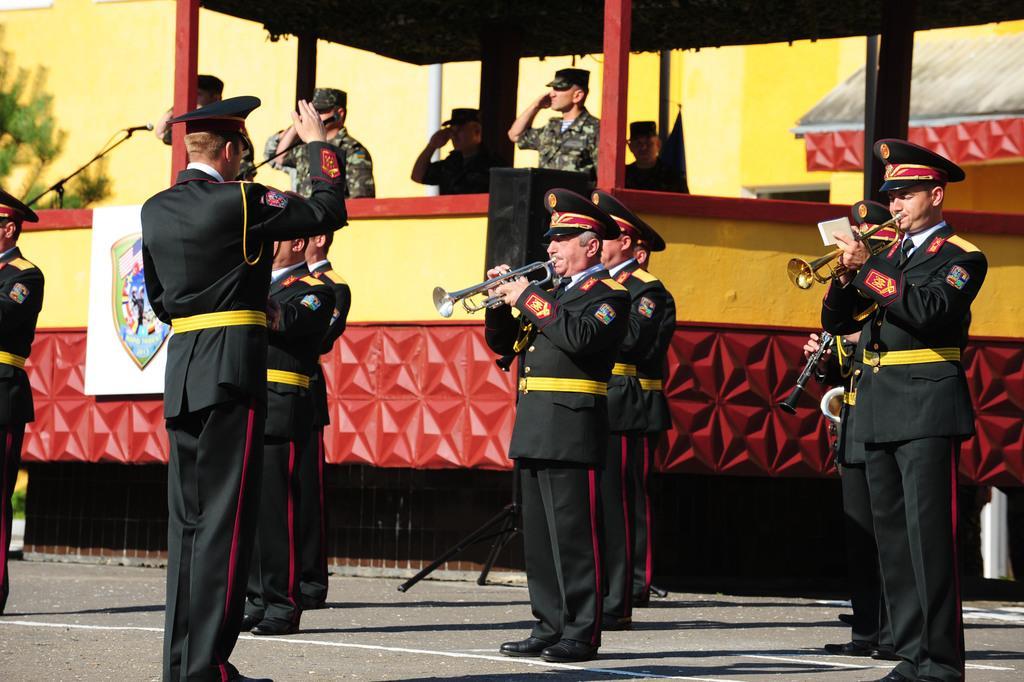Please provide a concise description of this image. In this image, there are a few people. We can see the shed with poles and the wall with a board. We can see a microphone and a stand with an object. We can see the ground. We can also see an object on the right and a tree on the left. 